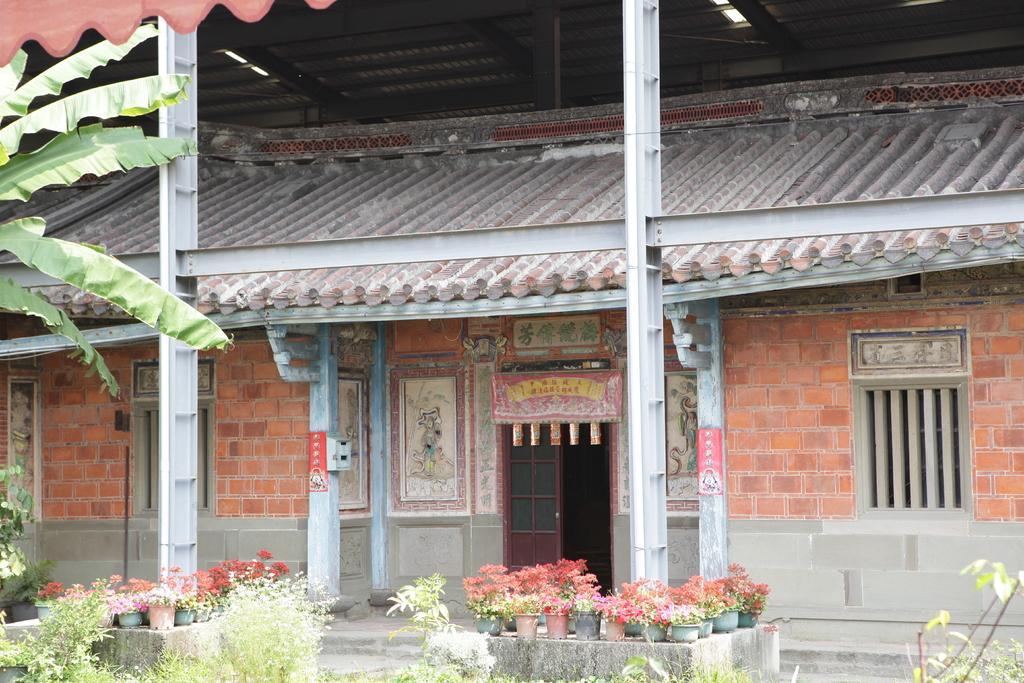Could you give a brief overview of what you see in this image? In this image we can see a house with roof, windows, door, pillars and some pictures on a wall. We can also see a tree and a cloth. On the bottom of the image we can see some plants with flowers in the pots. 